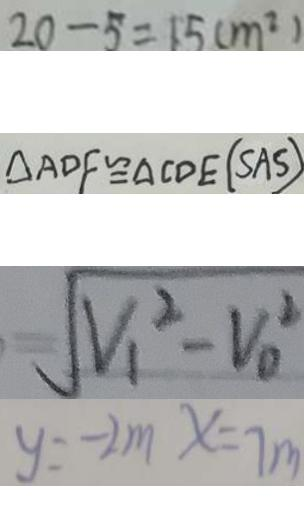Convert formula to latex. <formula><loc_0><loc_0><loc_500><loc_500>2 0 - 5 = 1 5 ( m ^ { 2 } ) 
 \Delta A D F \cong \Delta C D E ( S A S ) 
 \sqrt { V _ { 1 } ^ { 2 } - V _ { 0 } ^ { 2 } } 
 y = - 2 m x = 7 m</formula> 